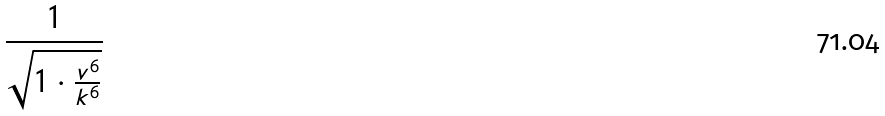Convert formula to latex. <formula><loc_0><loc_0><loc_500><loc_500>\frac { 1 } { \sqrt { 1 \cdot \frac { v ^ { 6 } } { k ^ { 6 } } } }</formula> 